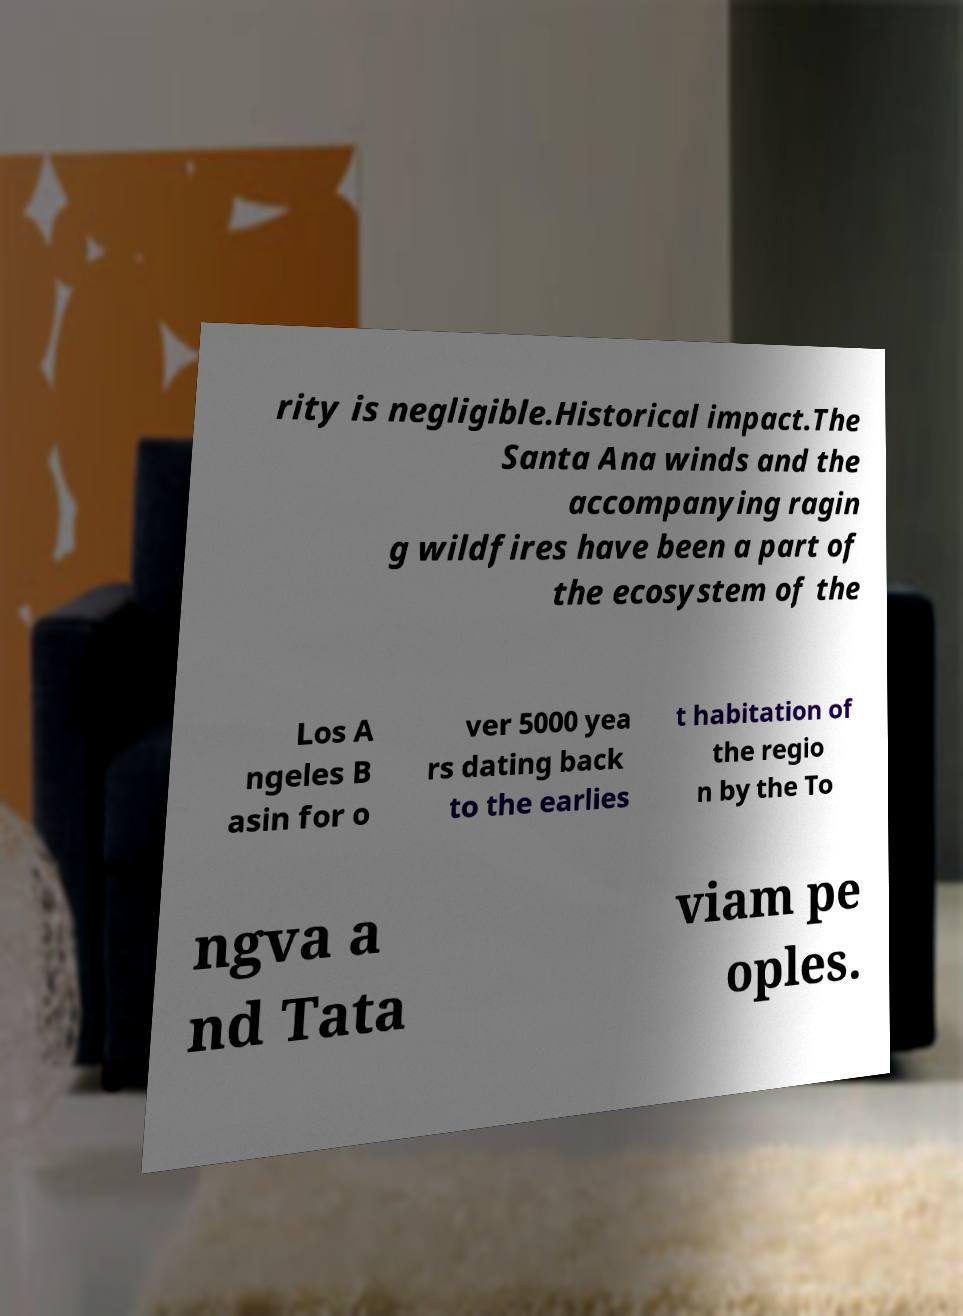For documentation purposes, I need the text within this image transcribed. Could you provide that? rity is negligible.Historical impact.The Santa Ana winds and the accompanying ragin g wildfires have been a part of the ecosystem of the Los A ngeles B asin for o ver 5000 yea rs dating back to the earlies t habitation of the regio n by the To ngva a nd Tata viam pe oples. 